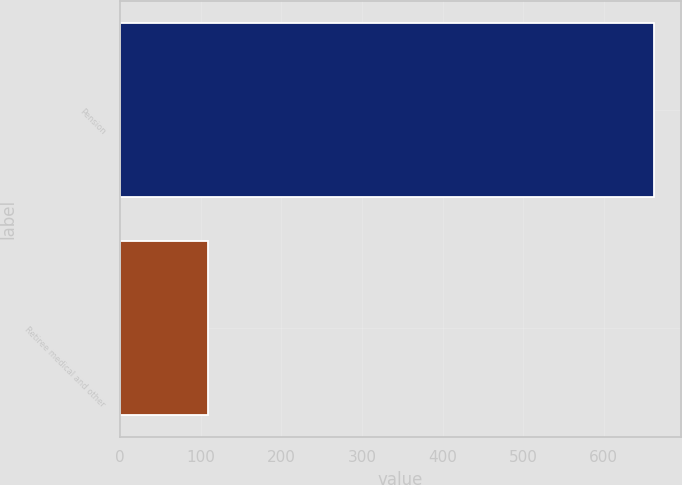Convert chart. <chart><loc_0><loc_0><loc_500><loc_500><bar_chart><fcel>Pension<fcel>Retiree medical and other<nl><fcel>662<fcel>109<nl></chart> 